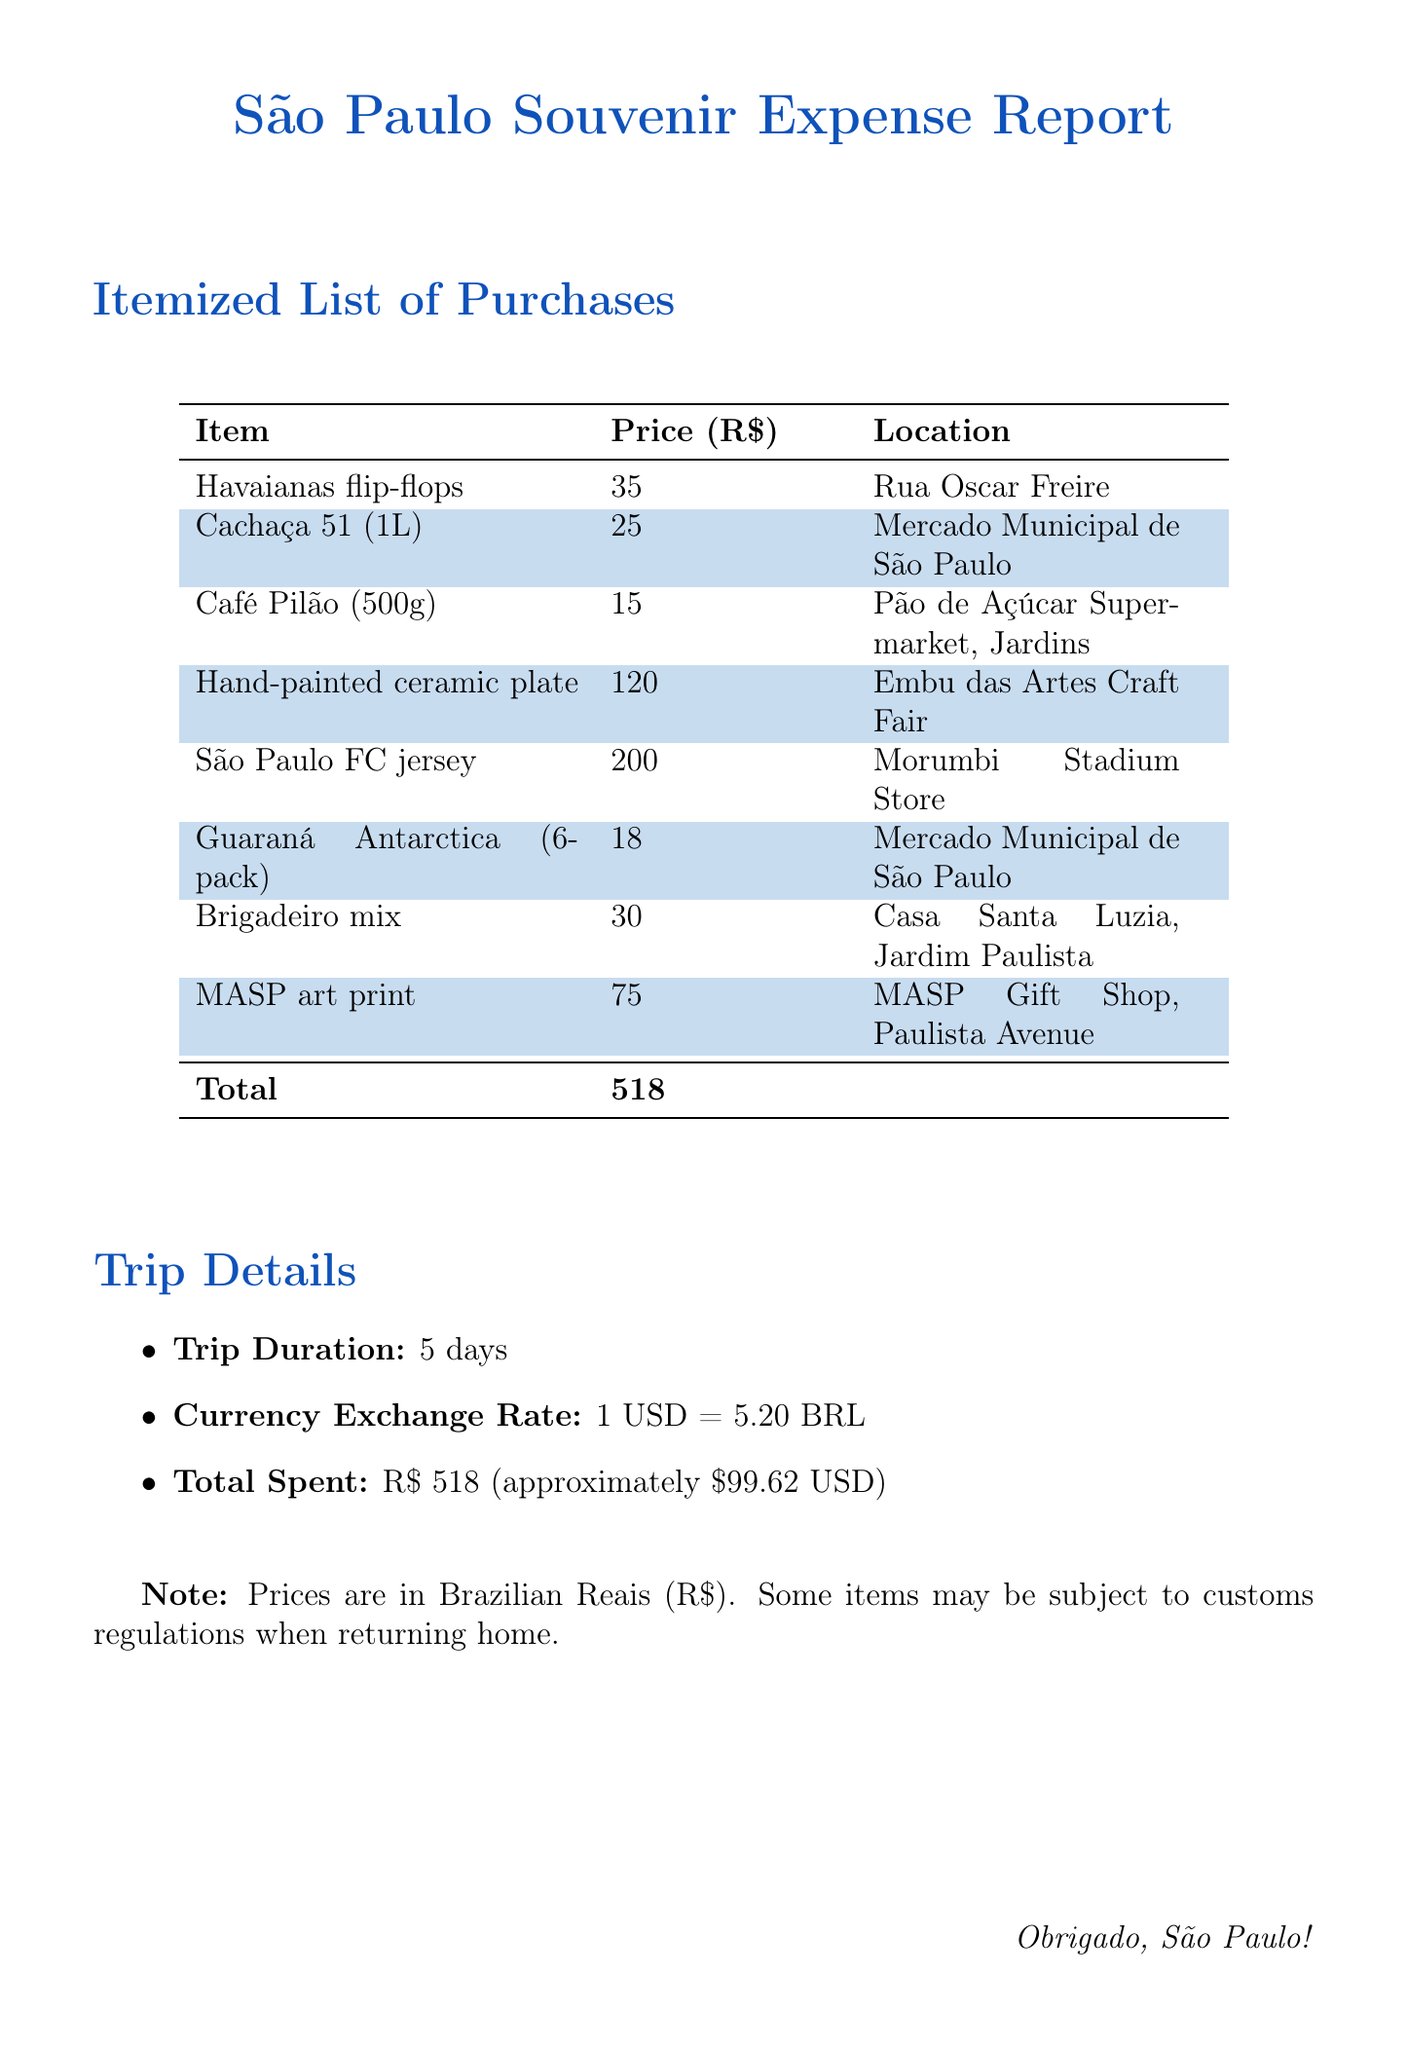What is the total amount spent on souvenirs? The total amount spent is provided at the end of the document as "Total Spent."
Answer: R$ 518 Where can you buy Havaianas flip-flops? The location for buying Havaianas flip-flops is indicated in the "Location" column of the souvenir table.
Answer: Rua Oscar Freire What is the price of the hand-painted ceramic plate? The price of the hand-painted ceramic plate can be found in the "Price" column of the souvenir table.
Answer: R$ 120 How many souvenirs were purchased in total? The total number of souvenirs can be counted from the list provided in the document.
Answer: 8 What was the trip duration? The document specifies the duration of the trip within the "Trip Details" section.
Answer: 5 days Which souvenir was the most expensive? The most expensive souvenir is indicated by the highest price in the "Price" column.
Answer: São Paulo FC jersey What is the currency exchange rate mentioned in the document? The currency exchange rate is explicitly stated in the "Trip Details" section of the document.
Answer: 1 USD = 5.20 BRL What location sells Guaraná Antarctica? The location for purchasing Guaraná Antarctica is listed in the souvenir table.
Answer: Mercado Municipal de São Paulo 